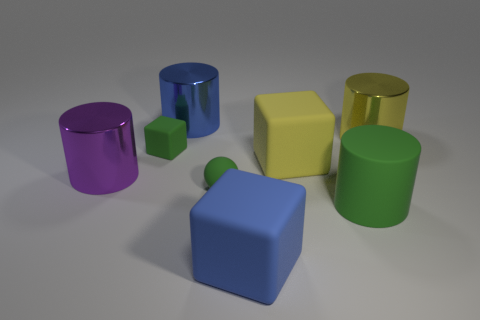Add 1 blue things. How many objects exist? 9 Subtract all blocks. How many objects are left? 5 Add 1 big yellow metallic things. How many big yellow metallic things are left? 2 Add 6 small green spheres. How many small green spheres exist? 7 Subtract 0 gray cylinders. How many objects are left? 8 Subtract all blue shiny cylinders. Subtract all green matte balls. How many objects are left? 6 